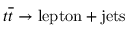<formula> <loc_0><loc_0><loc_500><loc_500>t \overline { t } \rightarrow l e p t o n + j e t s</formula> 